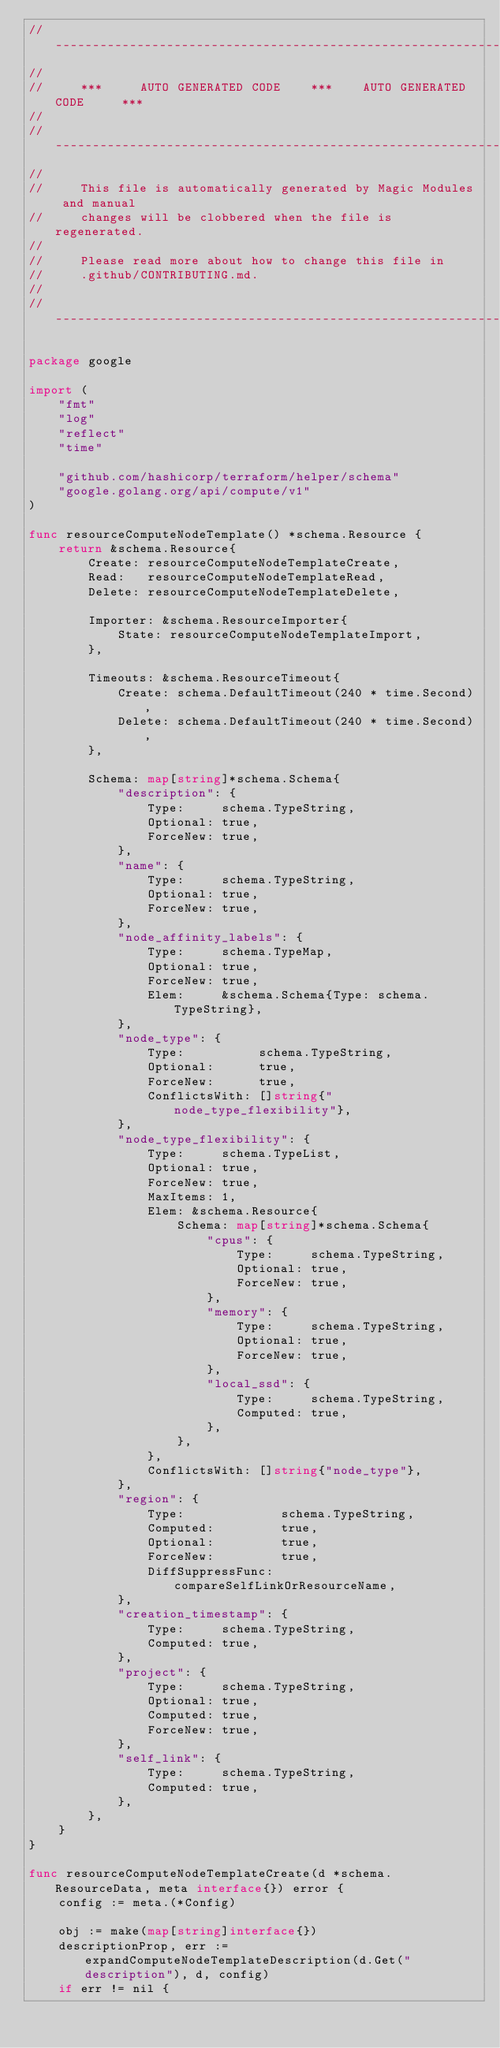Convert code to text. <code><loc_0><loc_0><loc_500><loc_500><_Go_>// ----------------------------------------------------------------------------
//
//     ***     AUTO GENERATED CODE    ***    AUTO GENERATED CODE     ***
//
// ----------------------------------------------------------------------------
//
//     This file is automatically generated by Magic Modules and manual
//     changes will be clobbered when the file is regenerated.
//
//     Please read more about how to change this file in
//     .github/CONTRIBUTING.md.
//
// ----------------------------------------------------------------------------

package google

import (
	"fmt"
	"log"
	"reflect"
	"time"

	"github.com/hashicorp/terraform/helper/schema"
	"google.golang.org/api/compute/v1"
)

func resourceComputeNodeTemplate() *schema.Resource {
	return &schema.Resource{
		Create: resourceComputeNodeTemplateCreate,
		Read:   resourceComputeNodeTemplateRead,
		Delete: resourceComputeNodeTemplateDelete,

		Importer: &schema.ResourceImporter{
			State: resourceComputeNodeTemplateImport,
		},

		Timeouts: &schema.ResourceTimeout{
			Create: schema.DefaultTimeout(240 * time.Second),
			Delete: schema.DefaultTimeout(240 * time.Second),
		},

		Schema: map[string]*schema.Schema{
			"description": {
				Type:     schema.TypeString,
				Optional: true,
				ForceNew: true,
			},
			"name": {
				Type:     schema.TypeString,
				Optional: true,
				ForceNew: true,
			},
			"node_affinity_labels": {
				Type:     schema.TypeMap,
				Optional: true,
				ForceNew: true,
				Elem:     &schema.Schema{Type: schema.TypeString},
			},
			"node_type": {
				Type:          schema.TypeString,
				Optional:      true,
				ForceNew:      true,
				ConflictsWith: []string{"node_type_flexibility"},
			},
			"node_type_flexibility": {
				Type:     schema.TypeList,
				Optional: true,
				ForceNew: true,
				MaxItems: 1,
				Elem: &schema.Resource{
					Schema: map[string]*schema.Schema{
						"cpus": {
							Type:     schema.TypeString,
							Optional: true,
							ForceNew: true,
						},
						"memory": {
							Type:     schema.TypeString,
							Optional: true,
							ForceNew: true,
						},
						"local_ssd": {
							Type:     schema.TypeString,
							Computed: true,
						},
					},
				},
				ConflictsWith: []string{"node_type"},
			},
			"region": {
				Type:             schema.TypeString,
				Computed:         true,
				Optional:         true,
				ForceNew:         true,
				DiffSuppressFunc: compareSelfLinkOrResourceName,
			},
			"creation_timestamp": {
				Type:     schema.TypeString,
				Computed: true,
			},
			"project": {
				Type:     schema.TypeString,
				Optional: true,
				Computed: true,
				ForceNew: true,
			},
			"self_link": {
				Type:     schema.TypeString,
				Computed: true,
			},
		},
	}
}

func resourceComputeNodeTemplateCreate(d *schema.ResourceData, meta interface{}) error {
	config := meta.(*Config)

	obj := make(map[string]interface{})
	descriptionProp, err := expandComputeNodeTemplateDescription(d.Get("description"), d, config)
	if err != nil {</code> 